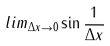<formula> <loc_0><loc_0><loc_500><loc_500>l i m _ { \Delta x \rightarrow 0 } \sin \frac { 1 } { \Delta x }</formula> 